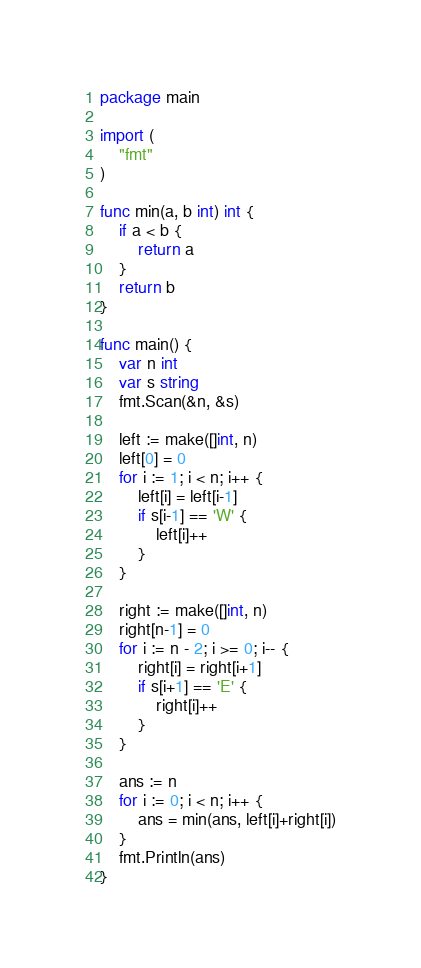Convert code to text. <code><loc_0><loc_0><loc_500><loc_500><_Go_>package main

import (
	"fmt"
)

func min(a, b int) int {
	if a < b {
		return a
	}
	return b
}

func main() {
	var n int
	var s string
	fmt.Scan(&n, &s)

	left := make([]int, n)
	left[0] = 0
	for i := 1; i < n; i++ {
		left[i] = left[i-1]
		if s[i-1] == 'W' {
			left[i]++
		}
	}

	right := make([]int, n)
	right[n-1] = 0
	for i := n - 2; i >= 0; i-- {
		right[i] = right[i+1]
		if s[i+1] == 'E' {
			right[i]++
		}
	}

	ans := n
	for i := 0; i < n; i++ {
		ans = min(ans, left[i]+right[i])
	}
	fmt.Println(ans)
}
</code> 